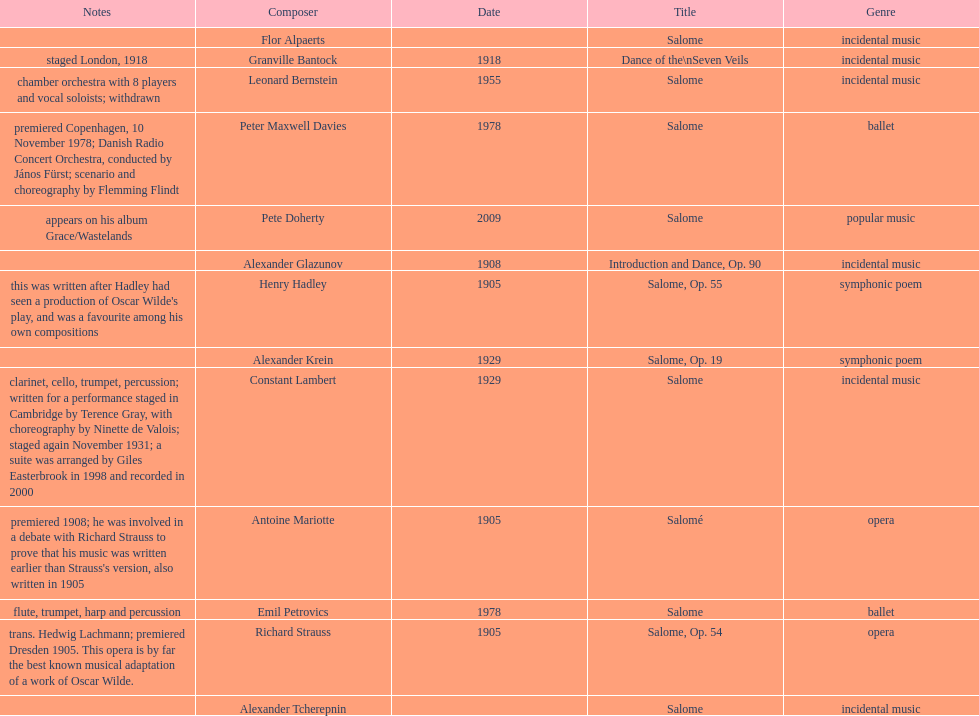What work was written after henry hadley had seen an oscar wilde play? Salome, Op. 55. Parse the full table. {'header': ['Notes', 'Composer', 'Date', 'Title', 'Genre'], 'rows': [['', 'Flor Alpaerts', '', 'Salome', 'incidental\xa0music'], ['staged London, 1918', 'Granville Bantock', '1918', 'Dance of the\\nSeven Veils', 'incidental music'], ['chamber orchestra with 8 players and vocal soloists; withdrawn', 'Leonard Bernstein', '1955', 'Salome', 'incidental music'], ['premiered Copenhagen, 10 November 1978; Danish Radio Concert Orchestra, conducted by János Fürst; scenario and choreography by Flemming Flindt', 'Peter\xa0Maxwell\xa0Davies', '1978', 'Salome', 'ballet'], ['appears on his album Grace/Wastelands', 'Pete Doherty', '2009', 'Salome', 'popular music'], ['', 'Alexander Glazunov', '1908', 'Introduction and Dance, Op. 90', 'incidental music'], ["this was written after Hadley had seen a production of Oscar Wilde's play, and was a favourite among his own compositions", 'Henry Hadley', '1905', 'Salome, Op. 55', 'symphonic poem'], ['', 'Alexander Krein', '1929', 'Salome, Op. 19', 'symphonic poem'], ['clarinet, cello, trumpet, percussion; written for a performance staged in Cambridge by Terence Gray, with choreography by Ninette de Valois; staged again November 1931; a suite was arranged by Giles Easterbrook in 1998 and recorded in 2000', 'Constant Lambert', '1929', 'Salome', 'incidental music'], ["premiered 1908; he was involved in a debate with Richard Strauss to prove that his music was written earlier than Strauss's version, also written in 1905", 'Antoine Mariotte', '1905', 'Salomé', 'opera'], ['flute, trumpet, harp and percussion', 'Emil Petrovics', '1978', 'Salome', 'ballet'], ['trans. Hedwig Lachmann; premiered Dresden 1905. This opera is by far the best known musical adaptation of a work of Oscar Wilde.', 'Richard Strauss', '1905', 'Salome, Op. 54', 'opera'], ['', 'Alexander\xa0Tcherepnin', '', 'Salome', 'incidental music']]} 